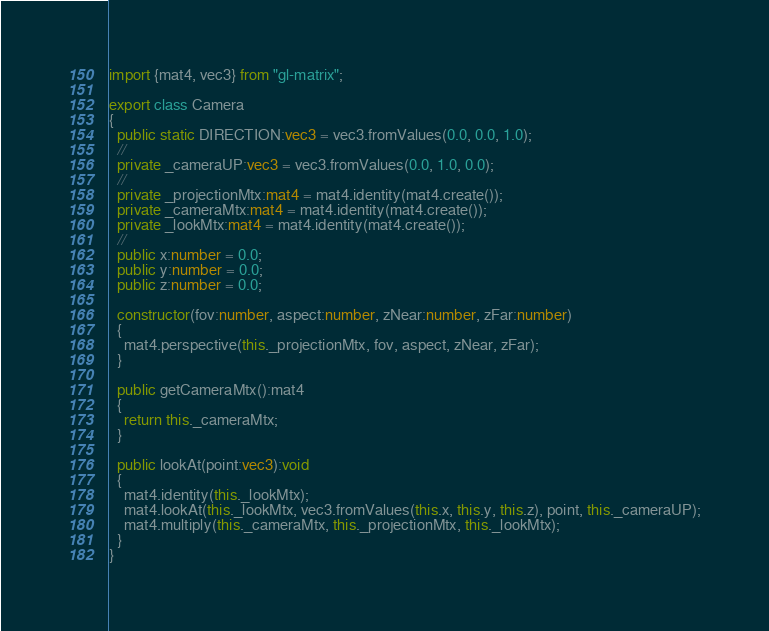Convert code to text. <code><loc_0><loc_0><loc_500><loc_500><_TypeScript_>import {mat4, vec3} from "gl-matrix";

export class Camera
{
  public static DIRECTION:vec3 = vec3.fromValues(0.0, 0.0, 1.0);
  //
  private _cameraUP:vec3 = vec3.fromValues(0.0, 1.0, 0.0);
  //
  private _projectionMtx:mat4 = mat4.identity(mat4.create());
  private _cameraMtx:mat4 = mat4.identity(mat4.create());
  private _lookMtx:mat4 = mat4.identity(mat4.create());
  //
  public x:number = 0.0;
  public y:number = 0.0;
  public z:number = 0.0;

  constructor(fov:number, aspect:number, zNear:number, zFar:number)
  {
    mat4.perspective(this._projectionMtx, fov, aspect, zNear, zFar);
  }

  public getCameraMtx():mat4
  {
    return this._cameraMtx;
  }

  public lookAt(point:vec3):void
  {
    mat4.identity(this._lookMtx);
    mat4.lookAt(this._lookMtx, vec3.fromValues(this.x, this.y, this.z), point, this._cameraUP);
    mat4.multiply(this._cameraMtx, this._projectionMtx, this._lookMtx);
  }
}
</code> 